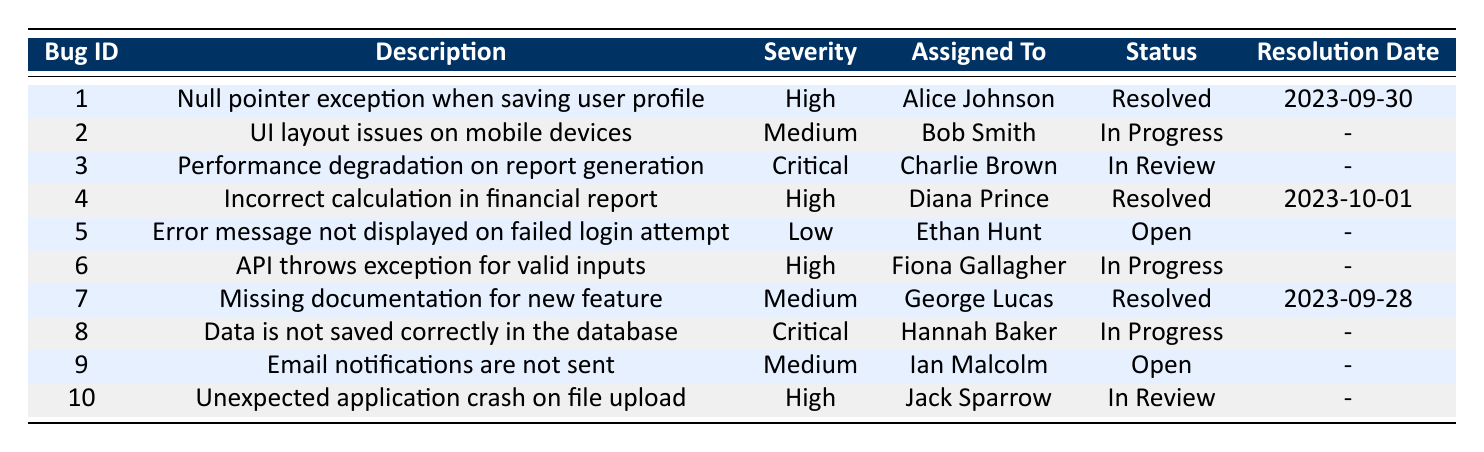What is the severity of the bug described as "API throws exception for valid inputs"? By referring to the table, I can locate the row for bug ID 6, which has the description "API throws exception for valid inputs". The severity for this bug is listed as "High".
Answer: High Who is assigned to the bug with ID 4? Looking at the table, I find that bug ID 4 is described as "Incorrect calculation in financial report". The person assigned to this bug is "Diana Prince".
Answer: Diana Prince How many bugs are currently marked as "In Progress"? In the table, I can see that there are three bugs with the status "In Progress" (bug IDs 2, 6, and 8). Therefore, there are a total of three bugs marked as "In Progress".
Answer: 3 Are there any bugs with the status "Open"? I can check the table for the status "Open". There are two bugs listed with this status (bug IDs 5 and 9). So, the answer is yes.
Answer: Yes Which bug has the most recent resolution date? To find the most recent resolution date, I look at the resolution dates for all resolved bugs in the table (2023-09-30 for bug ID 1, 2023-10-01 for bug ID 4, and 2023-09-28 for bug ID 7). The latest date is 2023-10-01 for bug ID 4.
Answer: Bug ID 4 How many high severity bugs are currently unresolved? In the table, I need to check for high severity bugs with the statuses "Open", "In Progress", or "In Review". The unresolved high severity bugs are bug IDs 6 and 10. Thus, there are two unresolved high severity bugs.
Answer: 2 What is the total number of bugs in the table? To find the total number of bugs, I count each entry in the table. There are a total of ten entries, so the total number of bugs is ten.
Answer: 10 Which assigned person has the highest number of resolved bugs? Upon reviewing the table, I see that Alice Johnson, Diana Prince, and George Lucas each have one resolved bug. There are no additional users with more resolved bugs than this, so they are tied.
Answer: Alice Johnson, Diana Prince, George Lucas (tied) Is the bug with ID 9 resolved? Checking the status for bug ID 9, which is "Email notifications are not sent", I see that it is marked as "Open". Therefore, the bug is not resolved.
Answer: No Which bug has the highest severity? In the table, the bugs with the highest severity are those marked as "Critical". There are two such bugs: bug IDs 3 and 8. Thus, both have the highest severity.
Answer: Bug IDs 3 and 8 